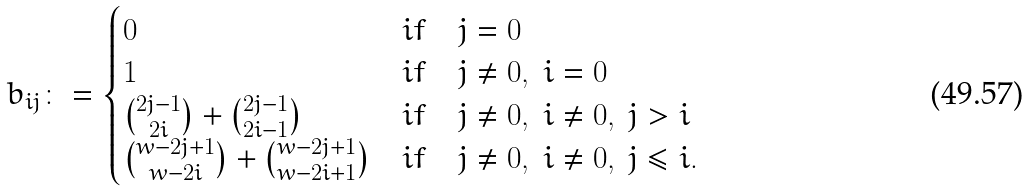<formula> <loc_0><loc_0><loc_500><loc_500>b _ { i j } \colon = \begin{cases} 0 & i f \quad j = 0 \\ 1 & i f \quad j \ne 0 , \ i = 0 \\ \binom { 2 j - 1 } { 2 i } + \binom { 2 j - 1 } { 2 i - 1 } & i f \quad j \ne 0 , \ i \ne 0 , \ j > i \\ \binom { w - 2 j + 1 } { w - 2 i } + \binom { w - 2 j + 1 } { w - 2 i + 1 } & i f \quad j \ne 0 , \ i \ne 0 , \ j \leq i . \end{cases}</formula> 